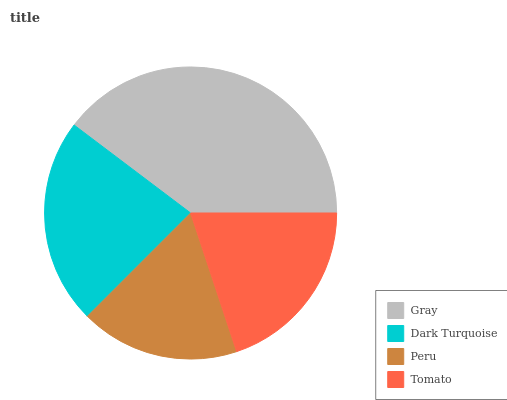Is Peru the minimum?
Answer yes or no. Yes. Is Gray the maximum?
Answer yes or no. Yes. Is Dark Turquoise the minimum?
Answer yes or no. No. Is Dark Turquoise the maximum?
Answer yes or no. No. Is Gray greater than Dark Turquoise?
Answer yes or no. Yes. Is Dark Turquoise less than Gray?
Answer yes or no. Yes. Is Dark Turquoise greater than Gray?
Answer yes or no. No. Is Gray less than Dark Turquoise?
Answer yes or no. No. Is Dark Turquoise the high median?
Answer yes or no. Yes. Is Tomato the low median?
Answer yes or no. Yes. Is Gray the high median?
Answer yes or no. No. Is Dark Turquoise the low median?
Answer yes or no. No. 